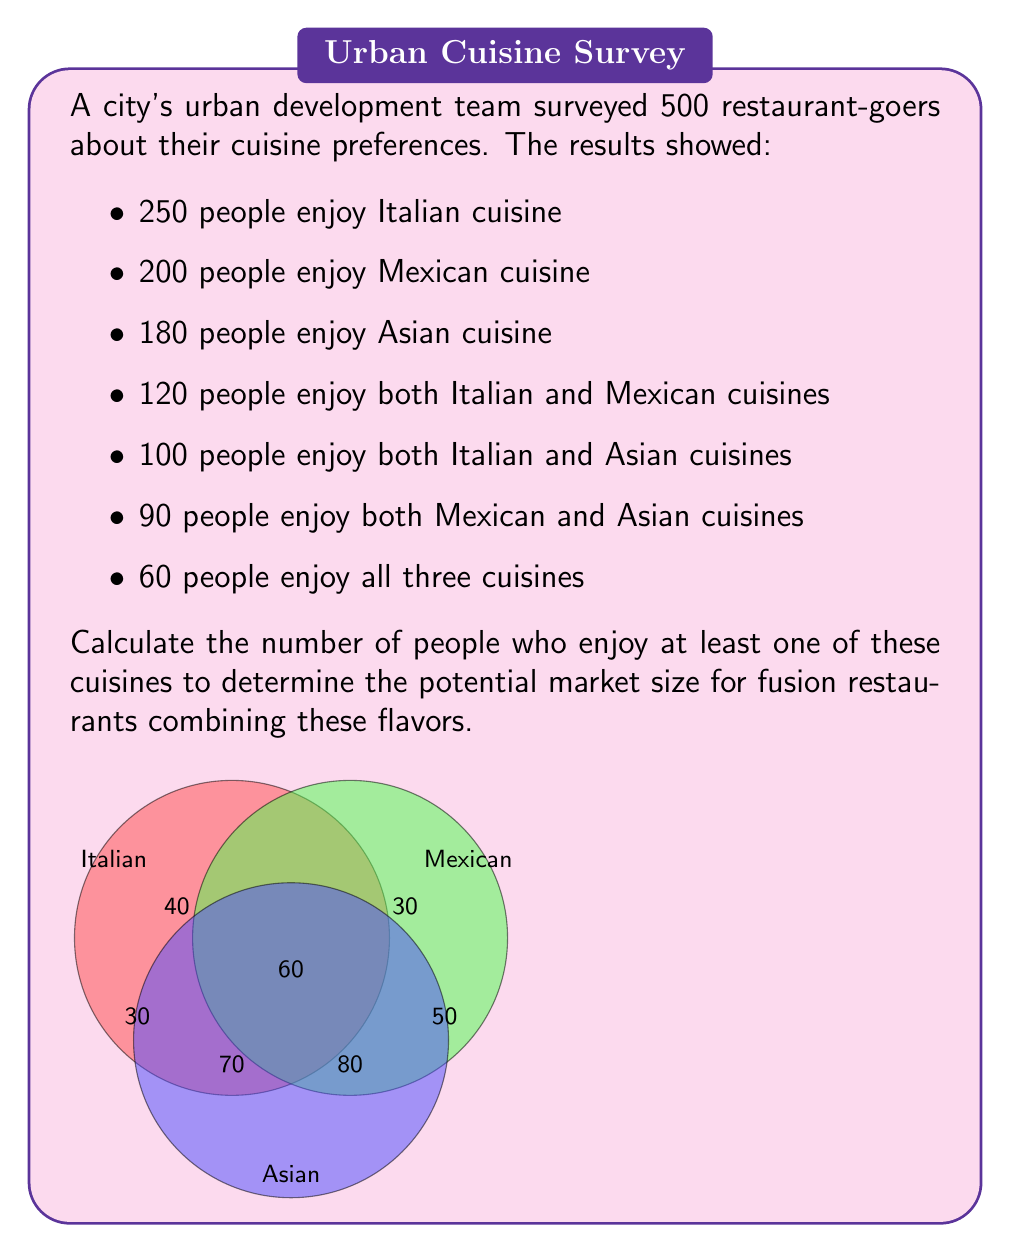Help me with this question. Let's approach this step-by-step using set theory:

1) Let $I$, $M$, and $A$ represent the sets of people who enjoy Italian, Mexican, and Asian cuisines respectively.

2) We're given:
   $|I| = 250$, $|M| = 200$, $|A| = 180$
   $|I \cap M| = 120$, $|I \cap A| = 100$, $|M \cap A| = 90$
   $|I \cap M \cap A| = 60$

3) To find the number of people who enjoy at least one cuisine, we need to calculate $|I \cup M \cup A|$.

4) We can use the Inclusion-Exclusion Principle:

   $$|I \cup M \cup A| = |I| + |M| + |A| - |I \cap M| - |I \cap A| - |M \cap A| + |I \cap M \cap A|$$

5) Substituting the given values:

   $$|I \cup M \cup A| = 250 + 200 + 180 - 120 - 100 - 90 + 60$$

6) Calculating:

   $$|I \cup M \cup A| = 630 - 310 + 60 = 380$$

Therefore, 380 people enjoy at least one of these cuisines.
Answer: 380 people 